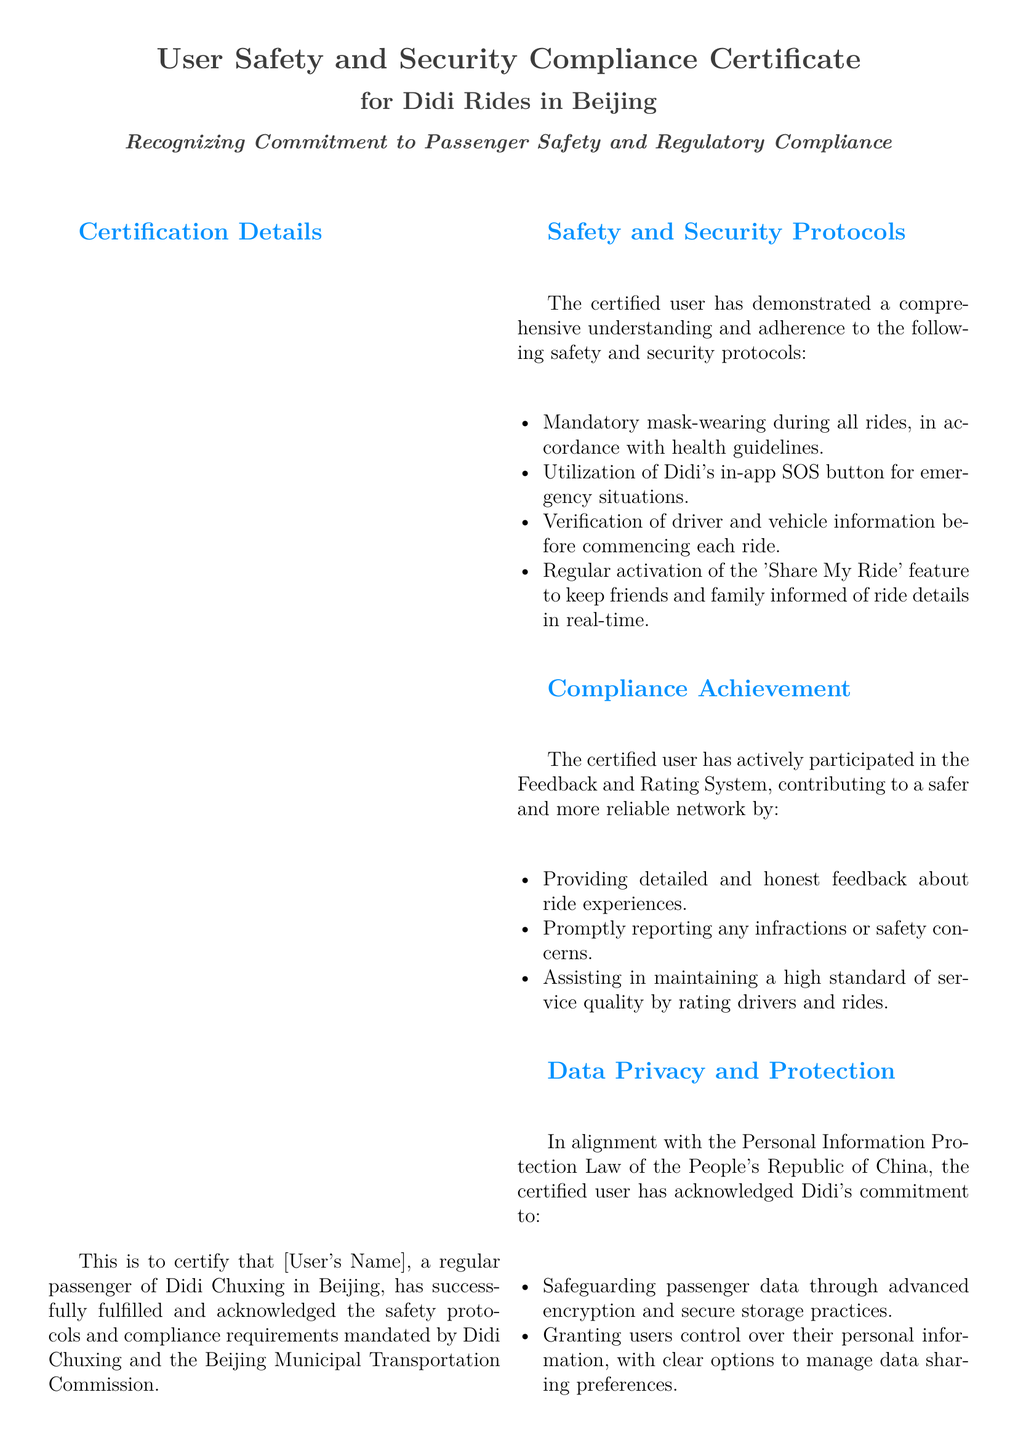What is the title of the certificate? The title of the certificate is stated at the top of the document, which is "User Safety and Security Compliance Certificate."
Answer: User Safety and Security Compliance Certificate Who is the certificate issued to? The document contains a placeholder for the recipient's name, indicated as "[User's Name]."
Answer: [User's Name] Which organization issued the certificate? The issuing body is mentioned in the "Certificate Issued By" section as "Didi Chuxing Safety and Compliance Department."
Answer: Didi Chuxing Safety and Compliance Department What training has the certified user completed? The document specifies "Didi Passenger Emergency Response Training" as the training completed by the user.
Answer: Didi Passenger Emergency Response Training What safety protocol involves real-time sharing of ride details? The document refers to the "Share My Ride" feature as the protocol for real-time sharing.
Answer: Share My Ride What law does Didi comply with regarding data privacy? The document mentions the "Personal Information Protection Law of the People's Republic of China" pertaining to data privacy compliance.
Answer: Personal Information Protection Law How many safety protocols are listed in the document? The document lists four safety and security protocols in the relevant section.
Answer: Four What is emphasized in the conclusion of the certificate? The conclusion stresses the dedication of the certified user to maintaining a safe and compliant transportation environment.
Answer: Dedication to safe transportation environment When was the certificate issued? The document has a placeholder for the issue date indicated as "[Date]."
Answer: [Date] 